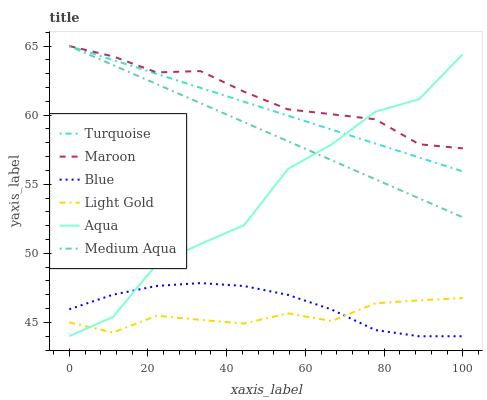Does Light Gold have the minimum area under the curve?
Answer yes or no. Yes. Does Maroon have the maximum area under the curve?
Answer yes or no. Yes. Does Turquoise have the minimum area under the curve?
Answer yes or no. No. Does Turquoise have the maximum area under the curve?
Answer yes or no. No. Is Turquoise the smoothest?
Answer yes or no. Yes. Is Aqua the roughest?
Answer yes or no. Yes. Is Aqua the smoothest?
Answer yes or no. No. Is Turquoise the roughest?
Answer yes or no. No. Does Blue have the lowest value?
Answer yes or no. Yes. Does Turquoise have the lowest value?
Answer yes or no. No. Does Medium Aqua have the highest value?
Answer yes or no. Yes. Does Aqua have the highest value?
Answer yes or no. No. Is Light Gold less than Turquoise?
Answer yes or no. Yes. Is Medium Aqua greater than Light Gold?
Answer yes or no. Yes. Does Light Gold intersect Aqua?
Answer yes or no. Yes. Is Light Gold less than Aqua?
Answer yes or no. No. Is Light Gold greater than Aqua?
Answer yes or no. No. Does Light Gold intersect Turquoise?
Answer yes or no. No. 